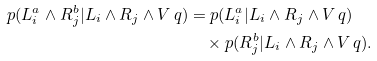<formula> <loc_0><loc_0><loc_500><loc_500>p ( L _ { i } ^ { a } \wedge R _ { j } ^ { b } | L _ { i } \wedge R _ { j } \wedge V \, q ) & = p ( L _ { i } ^ { a } | L _ { i } \wedge R _ { j } \wedge V \, q ) \\ & \quad \times p ( R _ { j } ^ { b } | L _ { i } \wedge R _ { j } \wedge V \, q ) .</formula> 